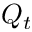<formula> <loc_0><loc_0><loc_500><loc_500>Q _ { t }</formula> 